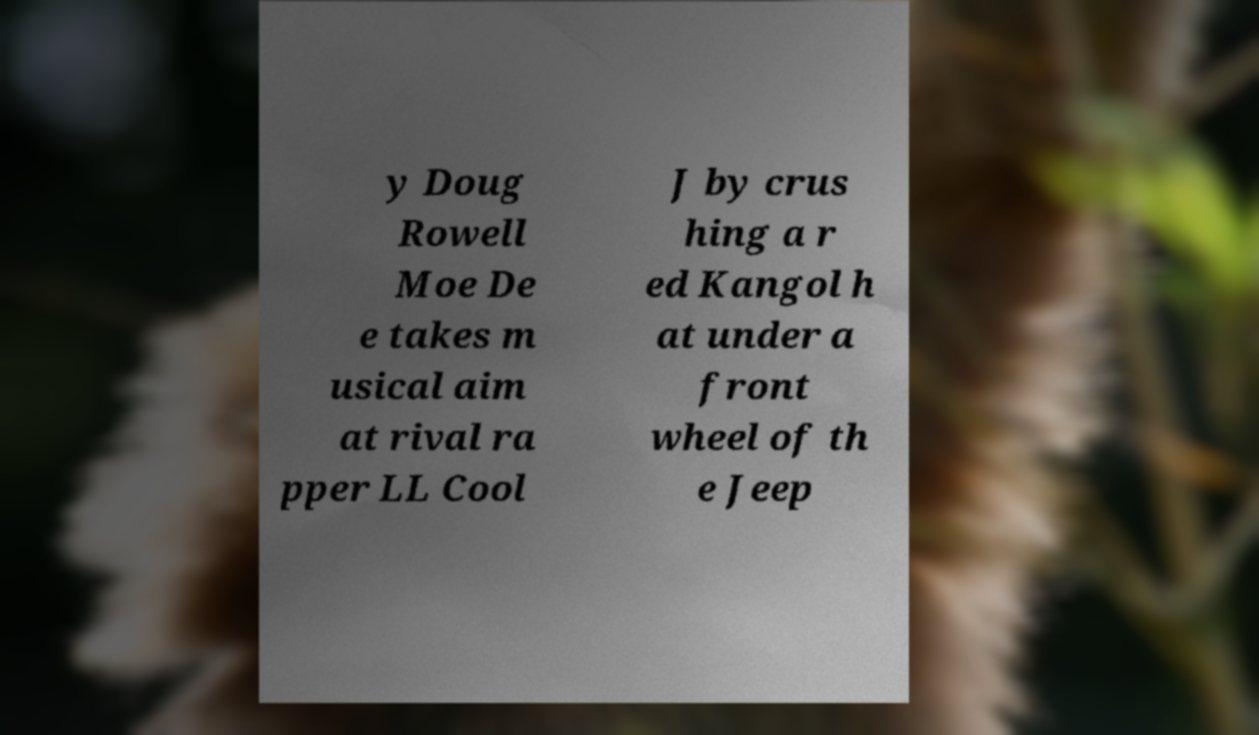Please read and relay the text visible in this image. What does it say? y Doug Rowell Moe De e takes m usical aim at rival ra pper LL Cool J by crus hing a r ed Kangol h at under a front wheel of th e Jeep 